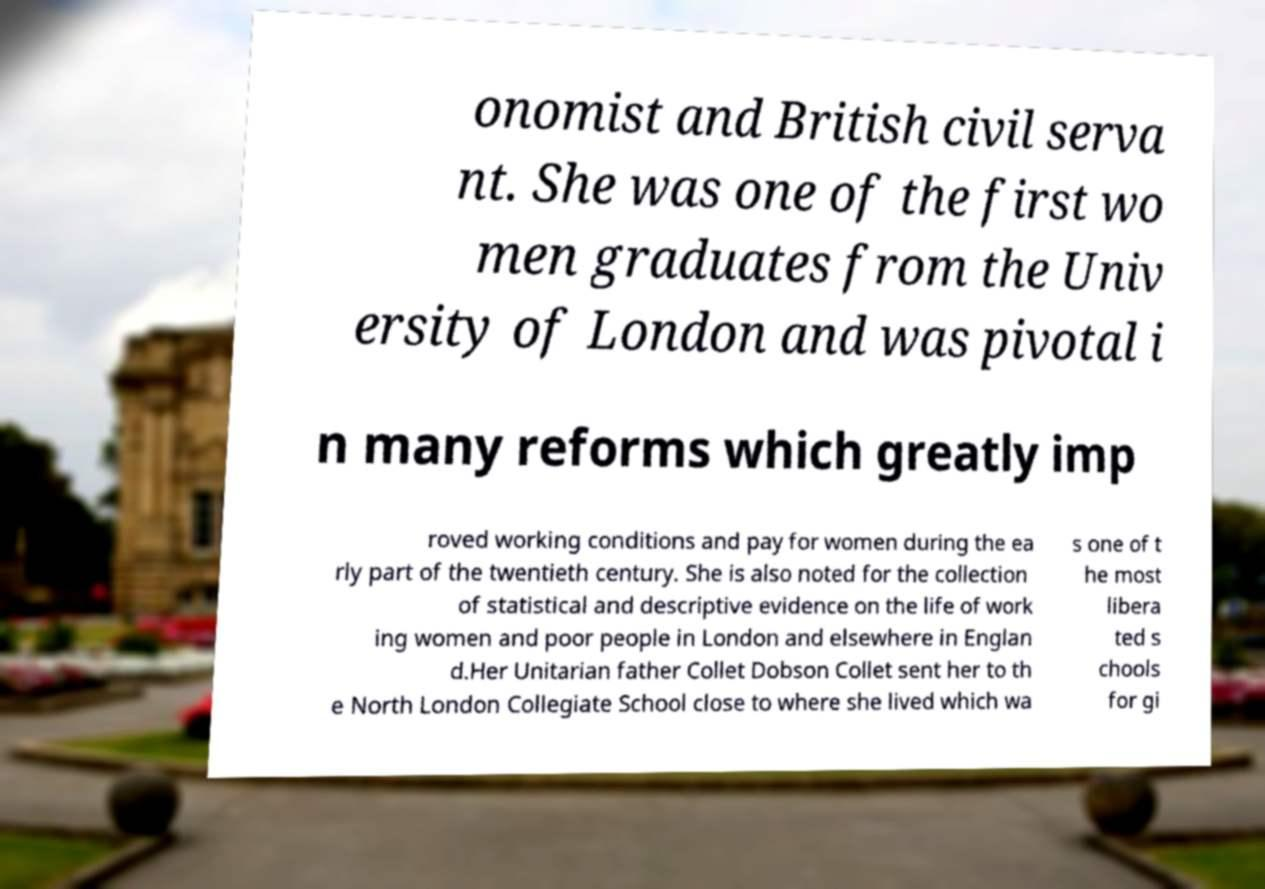What messages or text are displayed in this image? I need them in a readable, typed format. onomist and British civil serva nt. She was one of the first wo men graduates from the Univ ersity of London and was pivotal i n many reforms which greatly imp roved working conditions and pay for women during the ea rly part of the twentieth century. She is also noted for the collection of statistical and descriptive evidence on the life of work ing women and poor people in London and elsewhere in Englan d.Her Unitarian father Collet Dobson Collet sent her to th e North London Collegiate School close to where she lived which wa s one of t he most libera ted s chools for gi 